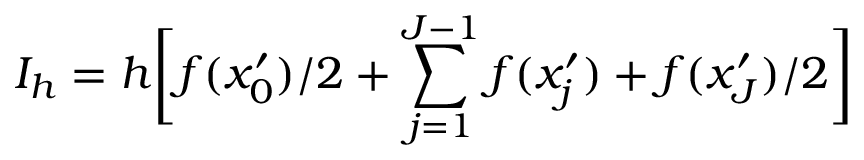<formula> <loc_0><loc_0><loc_500><loc_500>I _ { h } = h \left [ f ( x _ { 0 } ^ { \prime } ) / 2 + \sum _ { j = 1 } ^ { J - 1 } f ( x _ { j } ^ { \prime } ) + f ( x _ { J } ^ { \prime } ) / 2 \right ]</formula> 